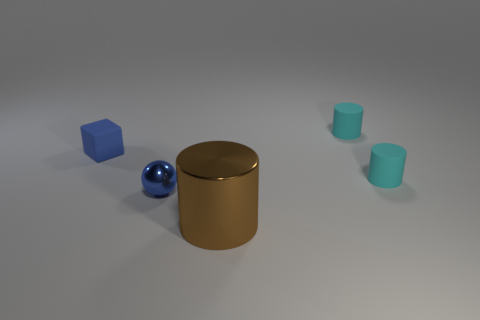Subtract all metallic cylinders. How many cylinders are left? 2 Add 5 small matte cubes. How many objects exist? 10 Subtract all brown cylinders. How many cylinders are left? 2 Subtract all cyan balls. How many cyan cylinders are left? 2 Subtract all spheres. How many objects are left? 4 Add 2 large metal cylinders. How many large metal cylinders exist? 3 Subtract 2 cyan cylinders. How many objects are left? 3 Subtract 1 cylinders. How many cylinders are left? 2 Subtract all green cylinders. Subtract all cyan spheres. How many cylinders are left? 3 Subtract all blue matte cubes. Subtract all small shiny spheres. How many objects are left? 3 